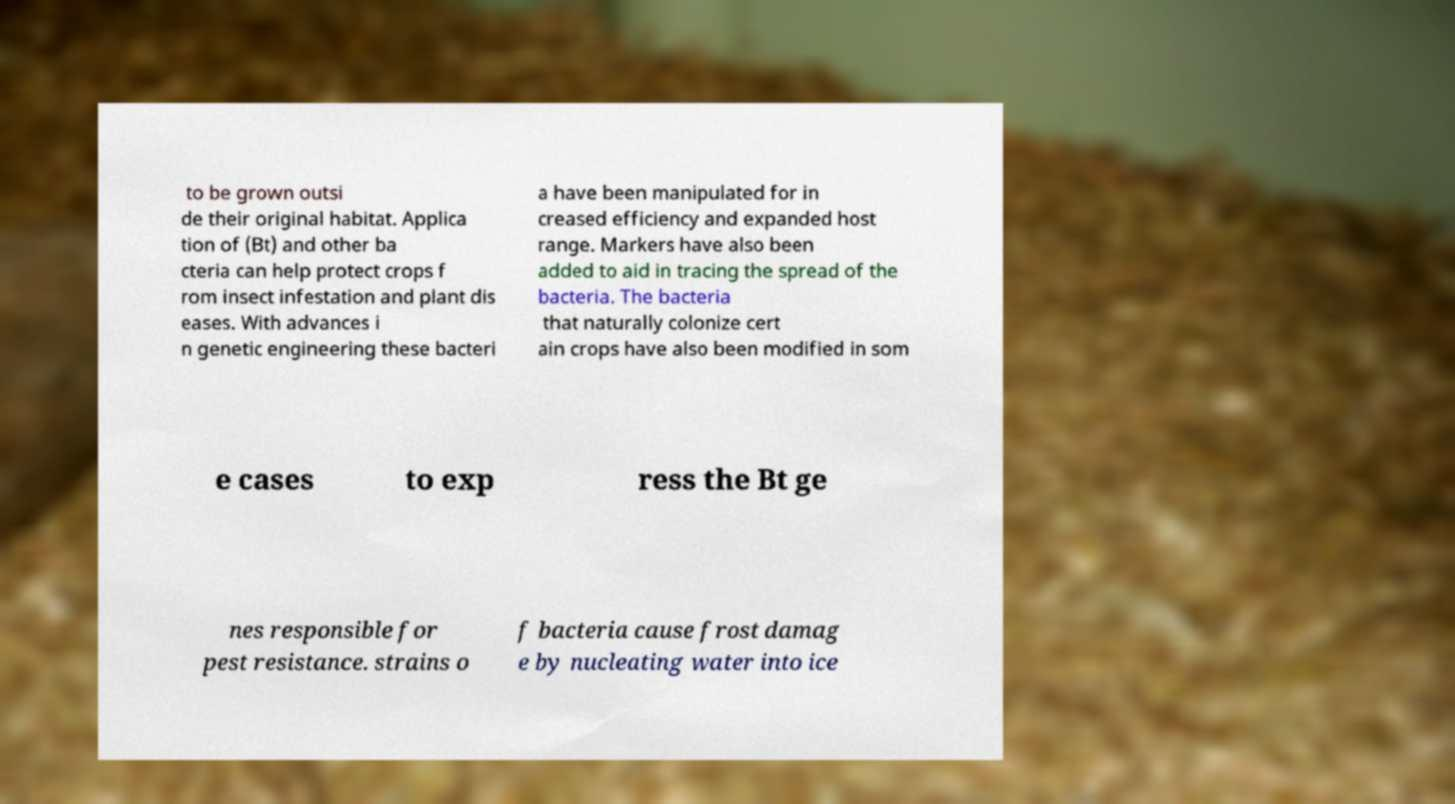I need the written content from this picture converted into text. Can you do that? to be grown outsi de their original habitat. Applica tion of (Bt) and other ba cteria can help protect crops f rom insect infestation and plant dis eases. With advances i n genetic engineering these bacteri a have been manipulated for in creased efficiency and expanded host range. Markers have also been added to aid in tracing the spread of the bacteria. The bacteria that naturally colonize cert ain crops have also been modified in som e cases to exp ress the Bt ge nes responsible for pest resistance. strains o f bacteria cause frost damag e by nucleating water into ice 